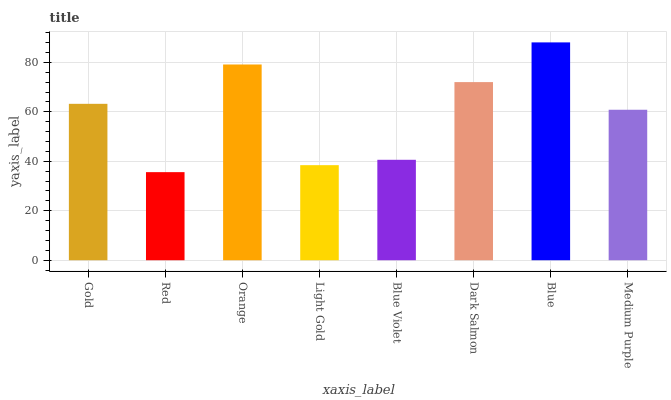Is Red the minimum?
Answer yes or no. Yes. Is Blue the maximum?
Answer yes or no. Yes. Is Orange the minimum?
Answer yes or no. No. Is Orange the maximum?
Answer yes or no. No. Is Orange greater than Red?
Answer yes or no. Yes. Is Red less than Orange?
Answer yes or no. Yes. Is Red greater than Orange?
Answer yes or no. No. Is Orange less than Red?
Answer yes or no. No. Is Gold the high median?
Answer yes or no. Yes. Is Medium Purple the low median?
Answer yes or no. Yes. Is Blue Violet the high median?
Answer yes or no. No. Is Red the low median?
Answer yes or no. No. 